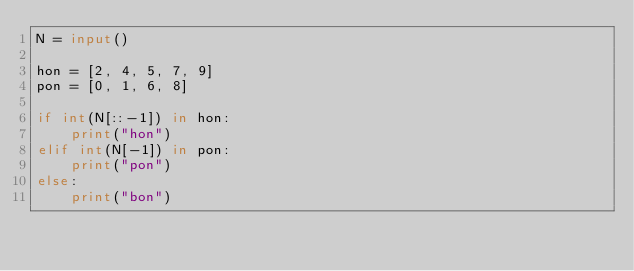Convert code to text. <code><loc_0><loc_0><loc_500><loc_500><_Python_>N = input()

hon = [2, 4, 5, 7, 9]
pon = [0, 1, 6, 8]

if int(N[::-1]) in hon:
    print("hon")
elif int(N[-1]) in pon:
    print("pon")
else:
    print("bon")</code> 